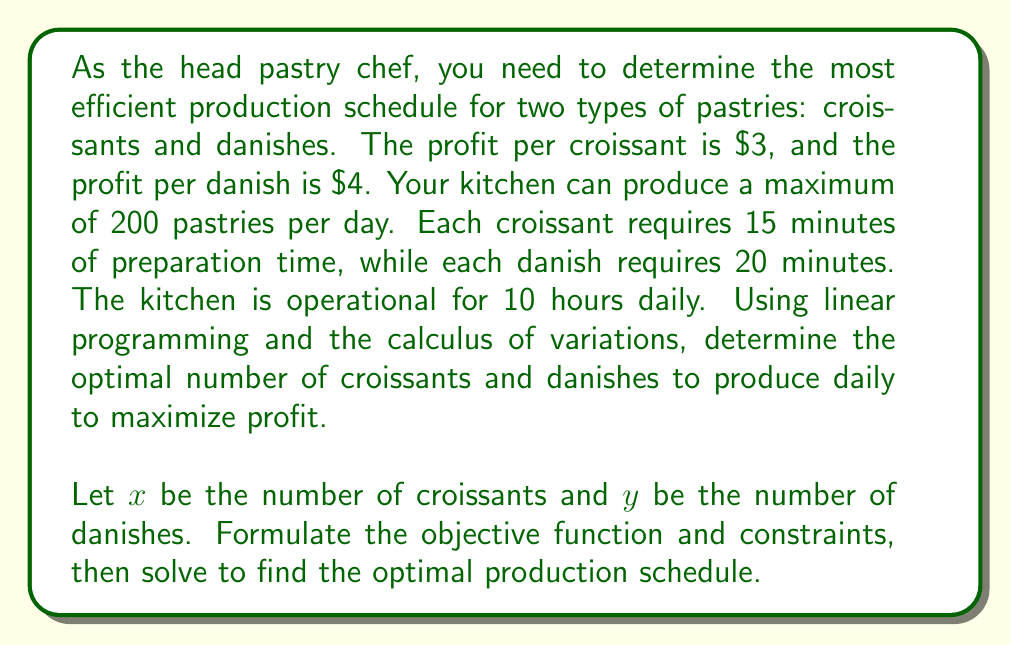What is the answer to this math problem? Let's approach this problem step-by-step using linear programming:

1) Define the objective function:
   Profit = $3x + $4y$

2) Identify the constraints:
   a) Total pastries: $x + y \leq 200$
   b) Time constraint: $15x + 20y \leq 600$ (10 hours = 600 minutes)
   c) Non-negativity: $x \geq 0, y \geq 0$

3) Set up the linear programming problem:
   Maximize: $Z = 3x + 4y$
   Subject to:
   $x + y \leq 200$
   $15x + 20y \leq 600$
   $x \geq 0, y \geq 0$

4) To solve this, we'll use the graphical method:

   [asy]
   import geometry;
   
   size(200);
   
   real xmax = 50;
   real ymax = 50;
   
   draw((0,0)--(xmax,0)--(xmax,ymax)--(0,ymax)--cycle);
   
   draw((0,200)--(200,0), blue);
   draw((0,30)--(40,0), red);
   
   label("x + y = 200", (100,95), blue);
   label("15x + 20y = 600", (20,25), red);
   
   dot((0,30));
   dot((40,0));
   dot((24,16));
   
   label("(0,30)", (0,32), E);
   label("(40,0)", (42,0), S);
   label("(24,16)", (26,16), SE);
   
   [/asy]

5) The feasible region is bounded by these lines and the axes. The optimal solution will be at one of the corner points.

6) Calculate the coordinates of the intersection point:
   $x + y = 200$
   $15x + 20y = 600$
   
   Solving these simultaneously:
   $x = 24, y = 16$

7) Evaluate the objective function at each corner point:
   $(0, 0): Z = 0$
   $(40, 0): Z = 120$
   $(0, 30): Z = 120$
   $(24, 16): Z = 3(24) + 4(16) = 136$

8) The maximum value occurs at $(24, 16)$, which represents 24 croissants and 16 danishes.

This solution can be verified using the calculus of variations, but the linear programming approach is sufficient for this problem.
Answer: 24 croissants and 16 danishes 